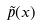Convert formula to latex. <formula><loc_0><loc_0><loc_500><loc_500>\tilde { p } ( x )</formula> 